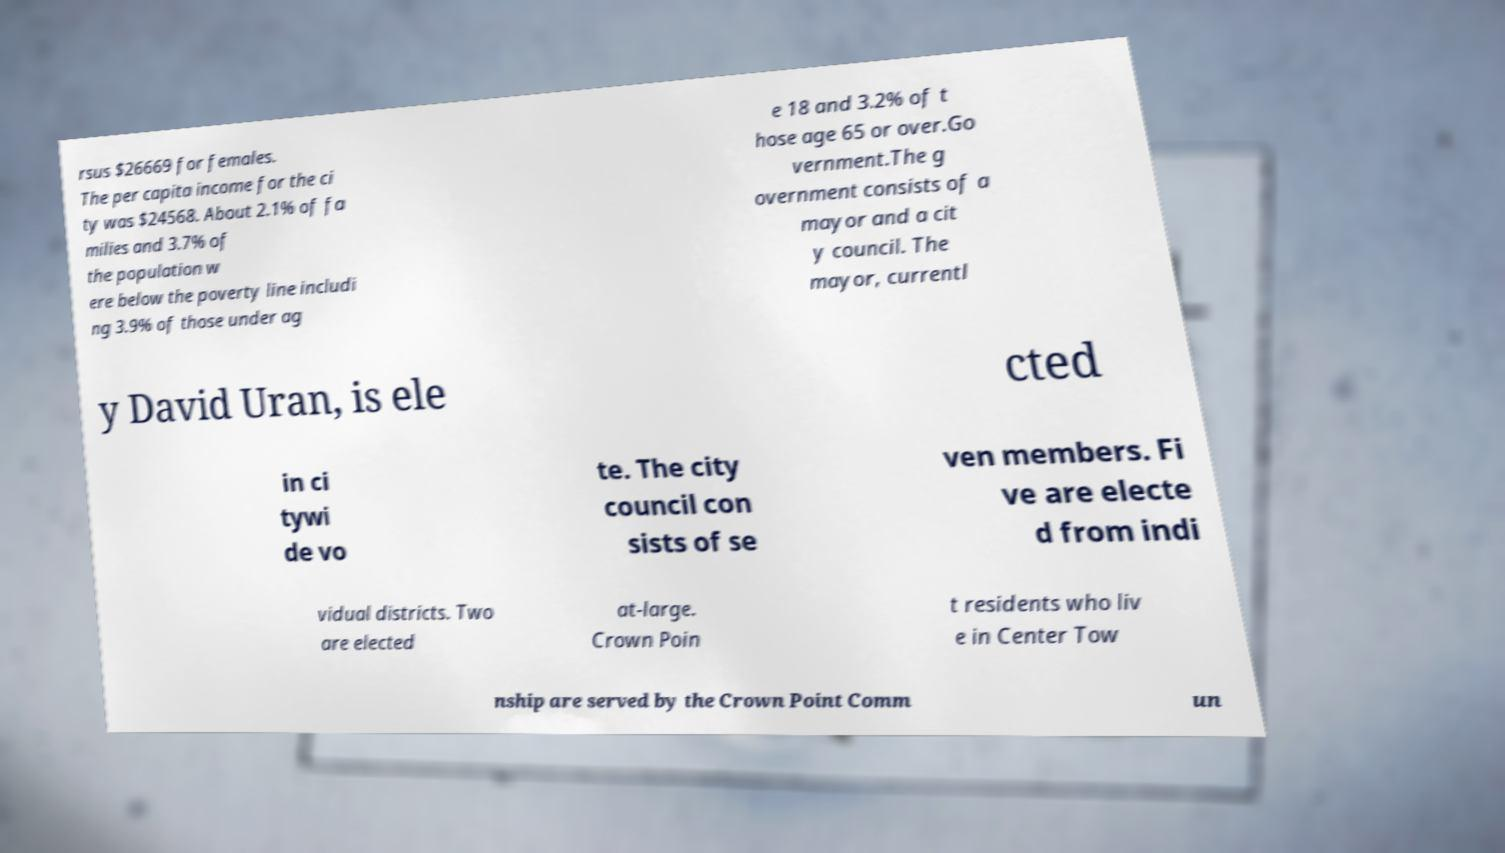What messages or text are displayed in this image? I need them in a readable, typed format. rsus $26669 for females. The per capita income for the ci ty was $24568. About 2.1% of fa milies and 3.7% of the population w ere below the poverty line includi ng 3.9% of those under ag e 18 and 3.2% of t hose age 65 or over.Go vernment.The g overnment consists of a mayor and a cit y council. The mayor, currentl y David Uran, is ele cted in ci tywi de vo te. The city council con sists of se ven members. Fi ve are electe d from indi vidual districts. Two are elected at-large. Crown Poin t residents who liv e in Center Tow nship are served by the Crown Point Comm un 